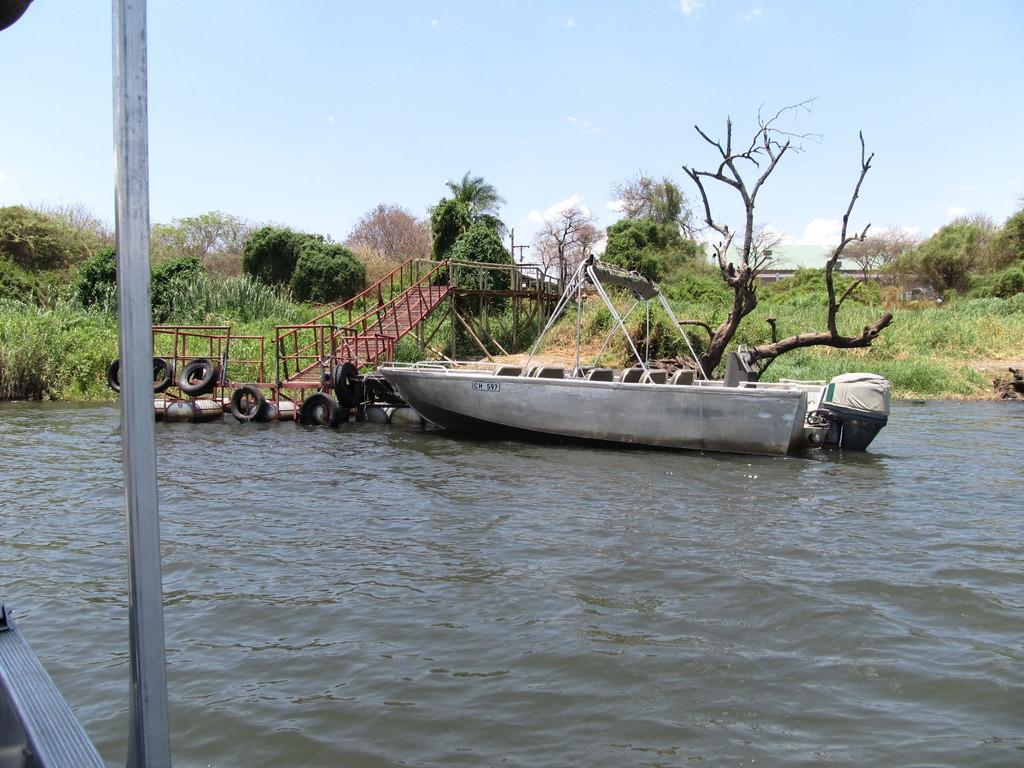How would you summarize this image in a sentence or two? In this image there is a boat in the water, beside that there are some iron stairs and trees in the ground. 